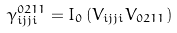<formula> <loc_0><loc_0><loc_500><loc_500>\gamma _ { i j j i } ^ { 0 2 1 1 } = I _ { 0 } \left ( V _ { i j j i } V _ { 0 2 1 1 } \right )</formula> 